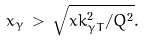<formula> <loc_0><loc_0><loc_500><loc_500>x _ { \gamma } \, > \, \sqrt { x k _ { \gamma T } ^ { 2 } / Q ^ { 2 } } .</formula> 